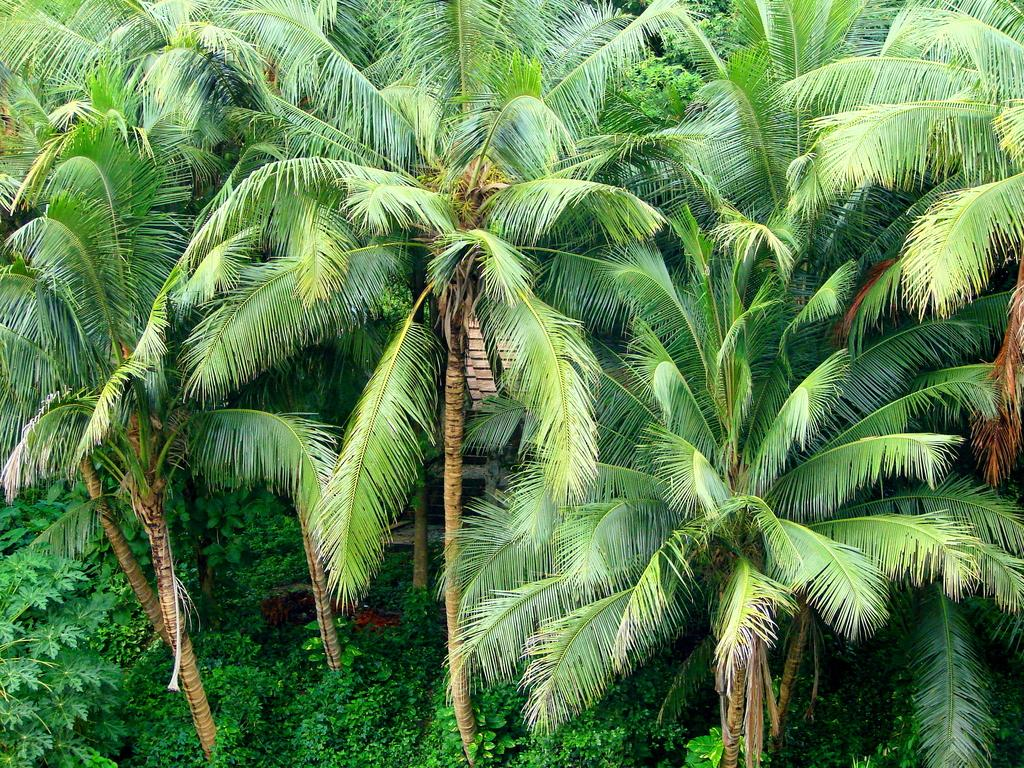What type of vegetation can be seen in the image? There are trees and plants in the image. Can you describe the trees in the image? The facts provided do not give specific details about the trees, but we can confirm that trees are present. What other type of vegetation is in the image besides trees? There are plants in the image. What color is the butter on the patch in the image? There is no butter or patch present in the image; it only features trees and plants. 